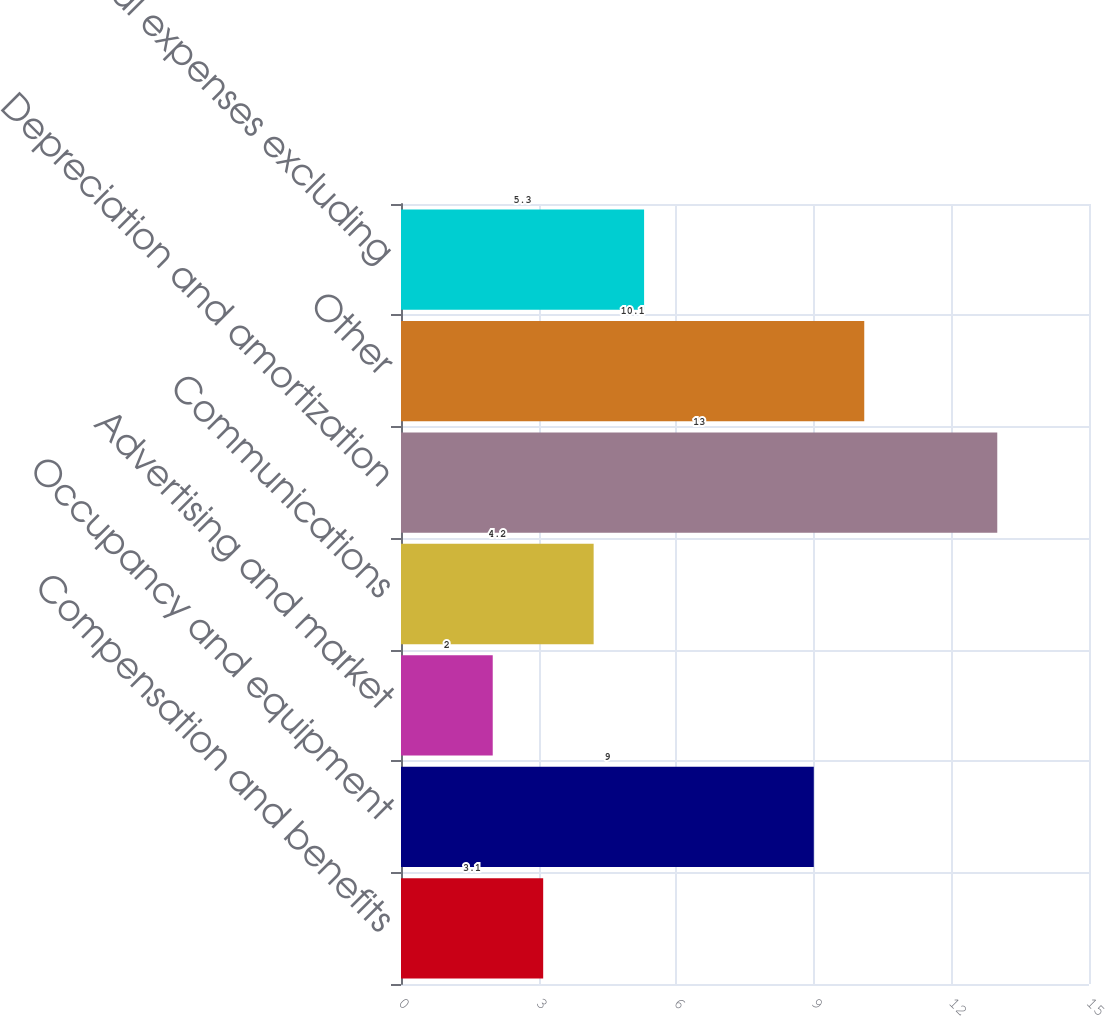Convert chart to OTSL. <chart><loc_0><loc_0><loc_500><loc_500><bar_chart><fcel>Compensation and benefits<fcel>Occupancy and equipment<fcel>Advertising and market<fcel>Communications<fcel>Depreciation and amortization<fcel>Other<fcel>Total expenses excluding<nl><fcel>3.1<fcel>9<fcel>2<fcel>4.2<fcel>13<fcel>10.1<fcel>5.3<nl></chart> 